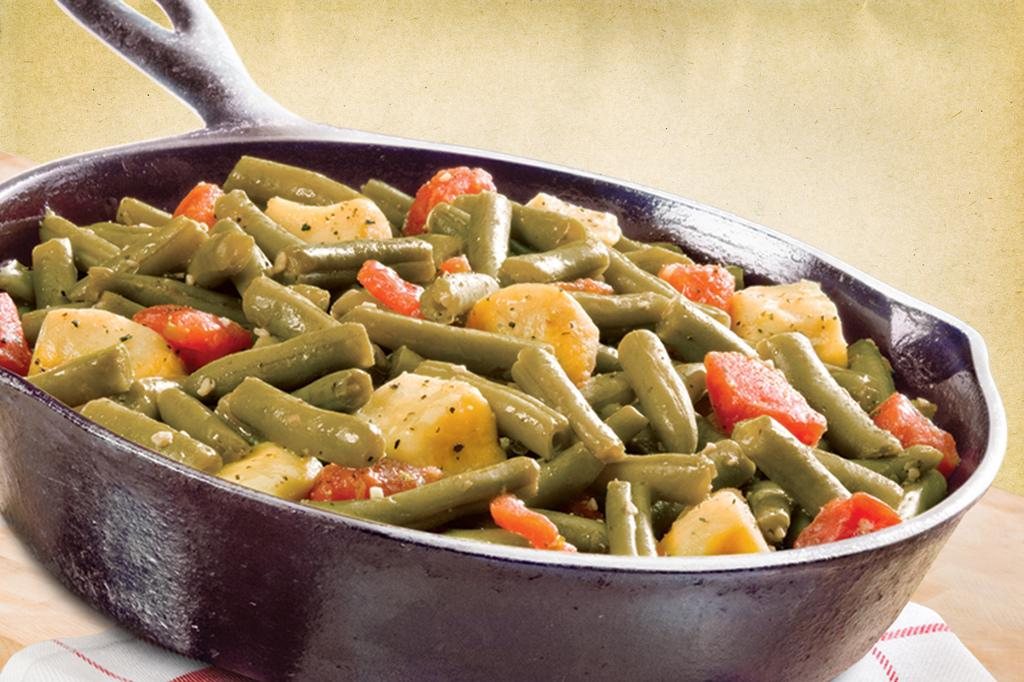What is in the pan that is visible in the image? There is a pan with fried vegetables in the image. Where is the pan located in the image? The pan is on a table in the image. What is placed below the pan on the table? There is a cloth below the pan on the table. What type of amusement can be seen in the image? There is no amusement present in the image; it features a pan with fried vegetables on a table with a cloth below it. 